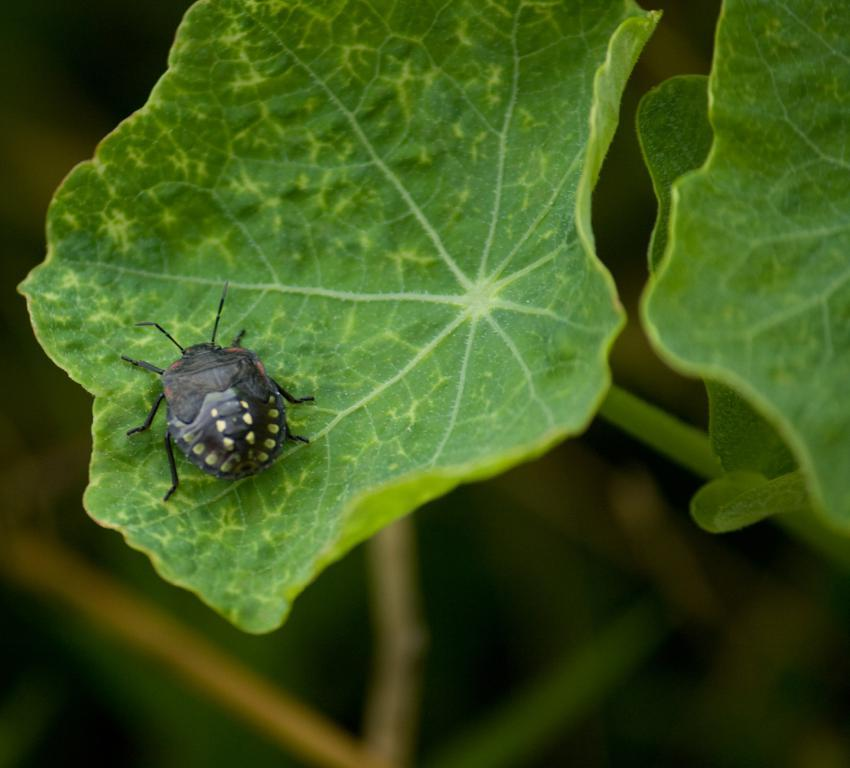What type of vegetation can be seen in the image? There are leaves in the image. Is there any wildlife present on the leaves? Yes, there is a bug on a leaf in the image. How would you describe the background of the image? The background of the image is blurry. Can you see the rat taking a breath in the image? There is no rat present in the image, so it is not possible to see it taking a breath. 